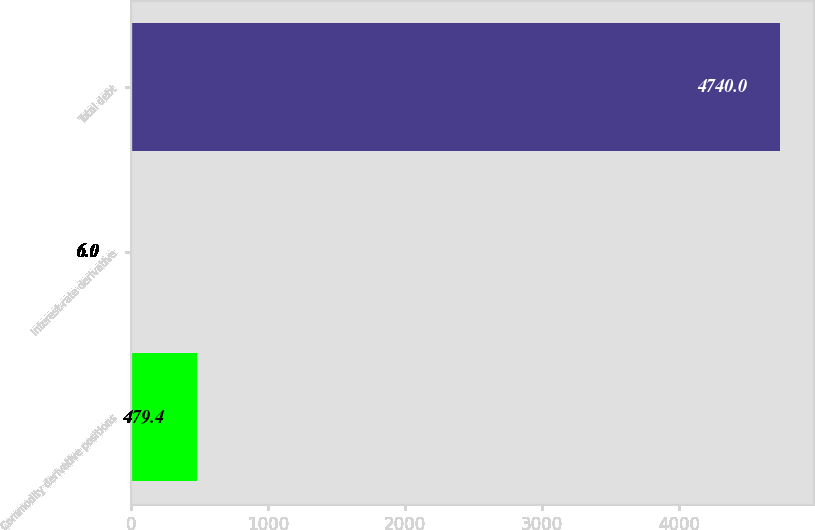Convert chart. <chart><loc_0><loc_0><loc_500><loc_500><bar_chart><fcel>Commodity derivative positions<fcel>Interest-rate derivative<fcel>Total debt<nl><fcel>479.4<fcel>6<fcel>4740<nl></chart> 